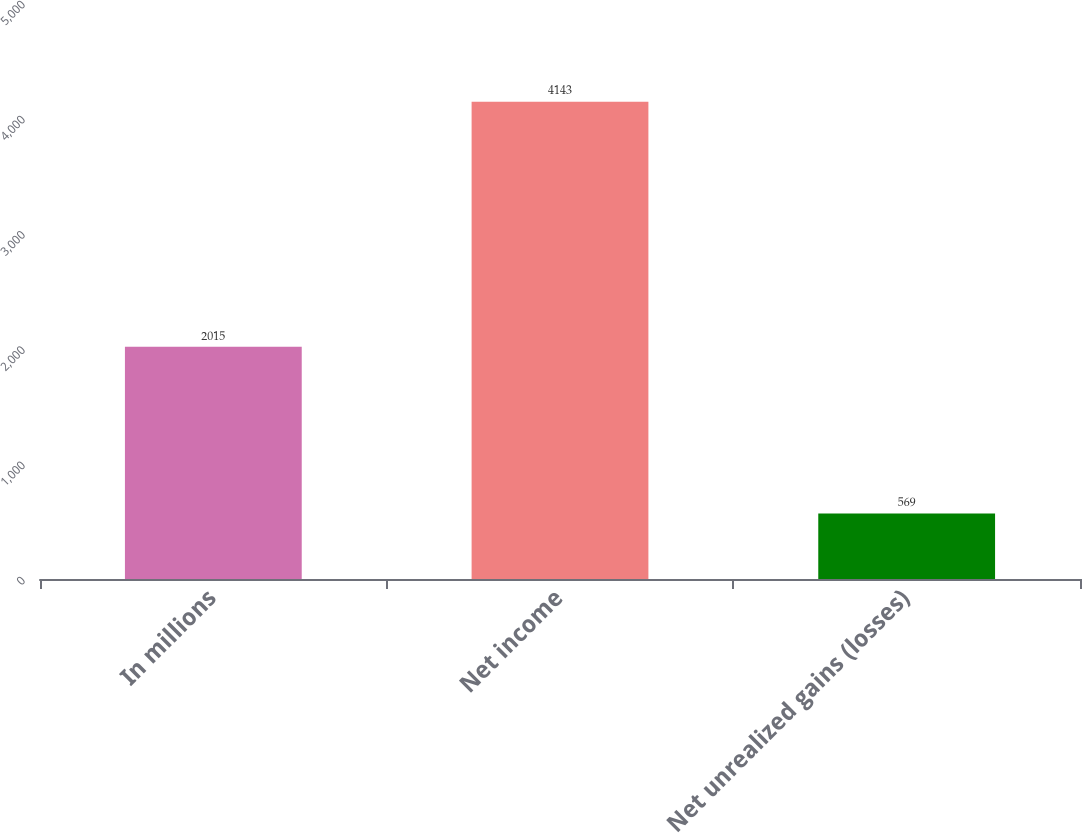Convert chart. <chart><loc_0><loc_0><loc_500><loc_500><bar_chart><fcel>In millions<fcel>Net income<fcel>Net unrealized gains (losses)<nl><fcel>2015<fcel>4143<fcel>569<nl></chart> 